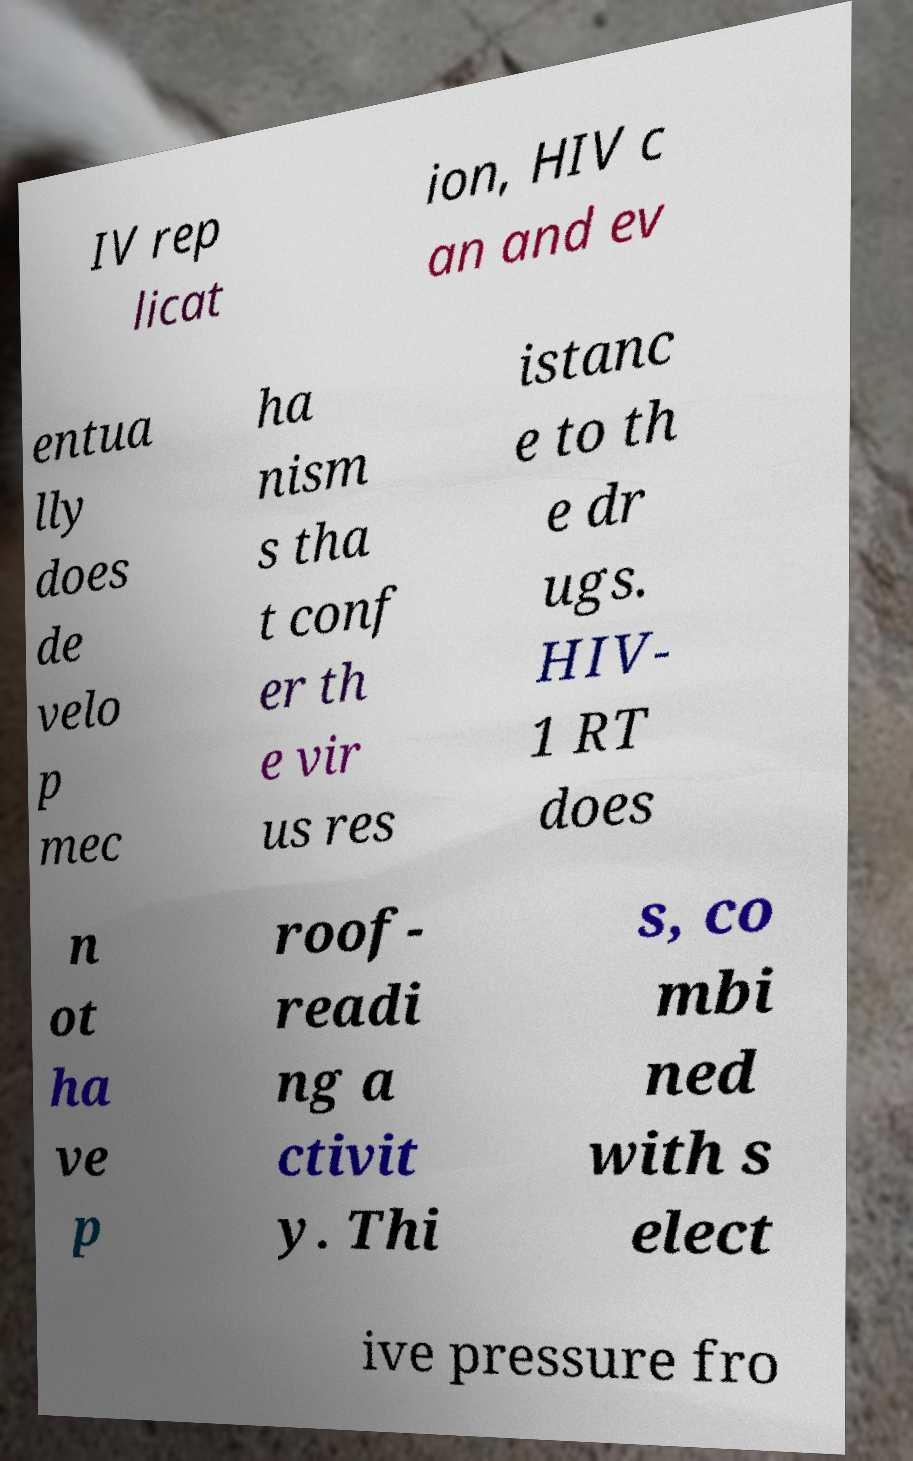For documentation purposes, I need the text within this image transcribed. Could you provide that? IV rep licat ion, HIV c an and ev entua lly does de velo p mec ha nism s tha t conf er th e vir us res istanc e to th e dr ugs. HIV- 1 RT does n ot ha ve p roof- readi ng a ctivit y. Thi s, co mbi ned with s elect ive pressure fro 